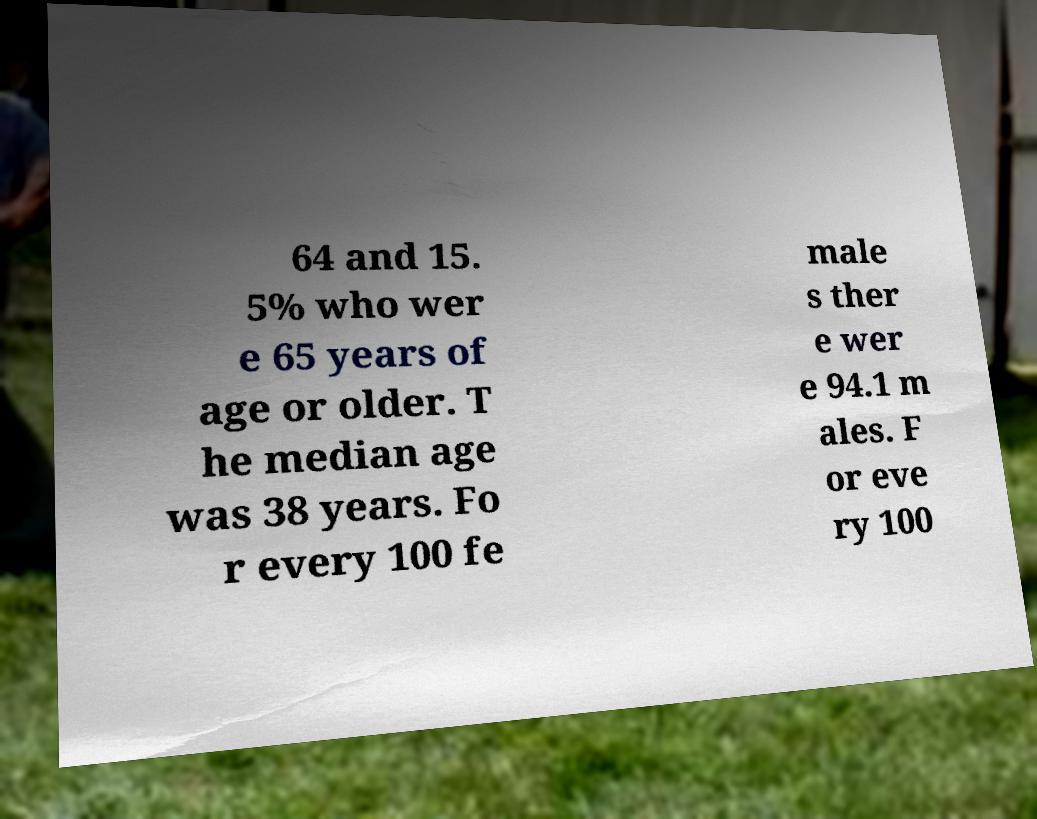I need the written content from this picture converted into text. Can you do that? 64 and 15. 5% who wer e 65 years of age or older. T he median age was 38 years. Fo r every 100 fe male s ther e wer e 94.1 m ales. F or eve ry 100 